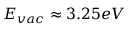Convert formula to latex. <formula><loc_0><loc_0><loc_500><loc_500>E _ { v a c } \approx 3 . 2 5 e V</formula> 